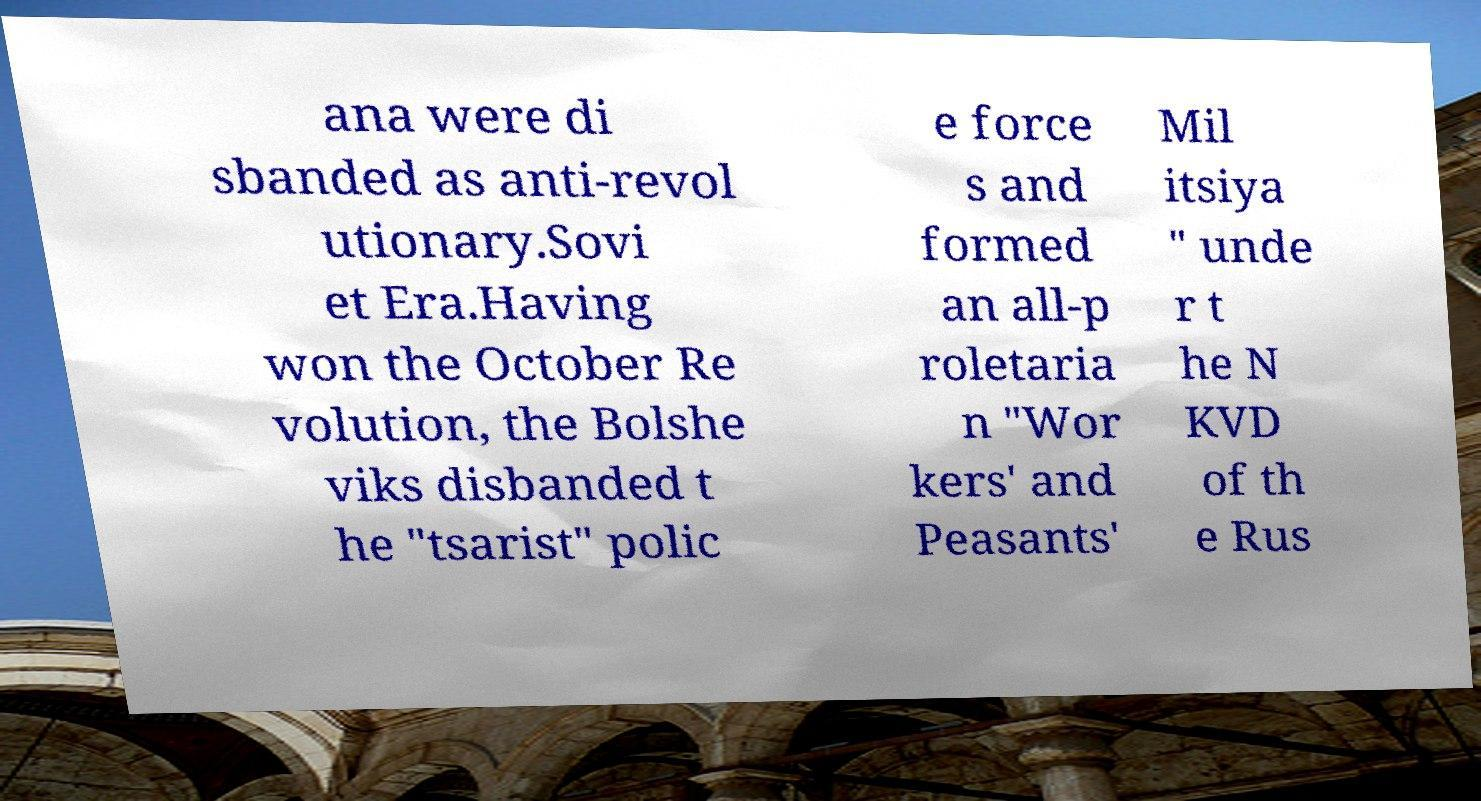There's text embedded in this image that I need extracted. Can you transcribe it verbatim? ana were di sbanded as anti-revol utionary.Sovi et Era.Having won the October Re volution, the Bolshe viks disbanded t he "tsarist" polic e force s and formed an all-p roletaria n "Wor kers' and Peasants' Mil itsiya " unde r t he N KVD of th e Rus 